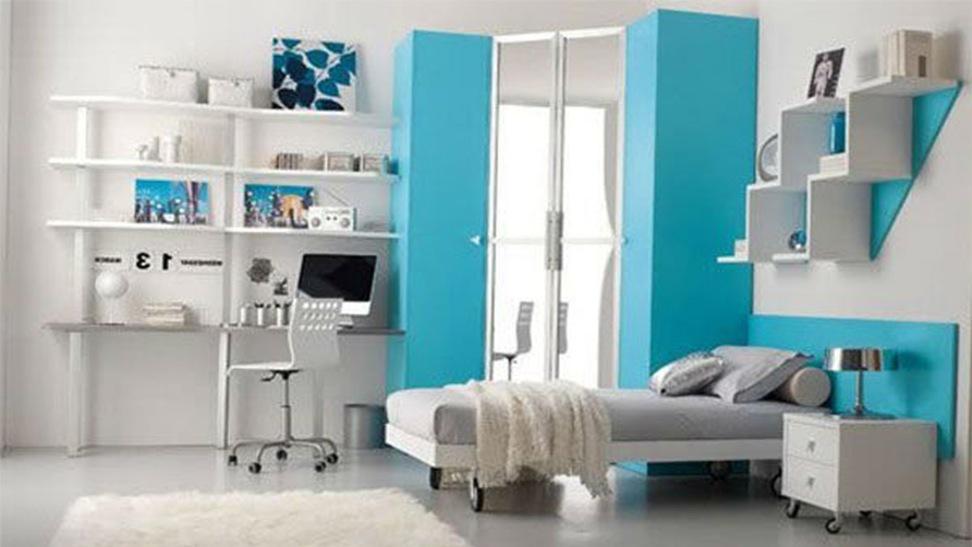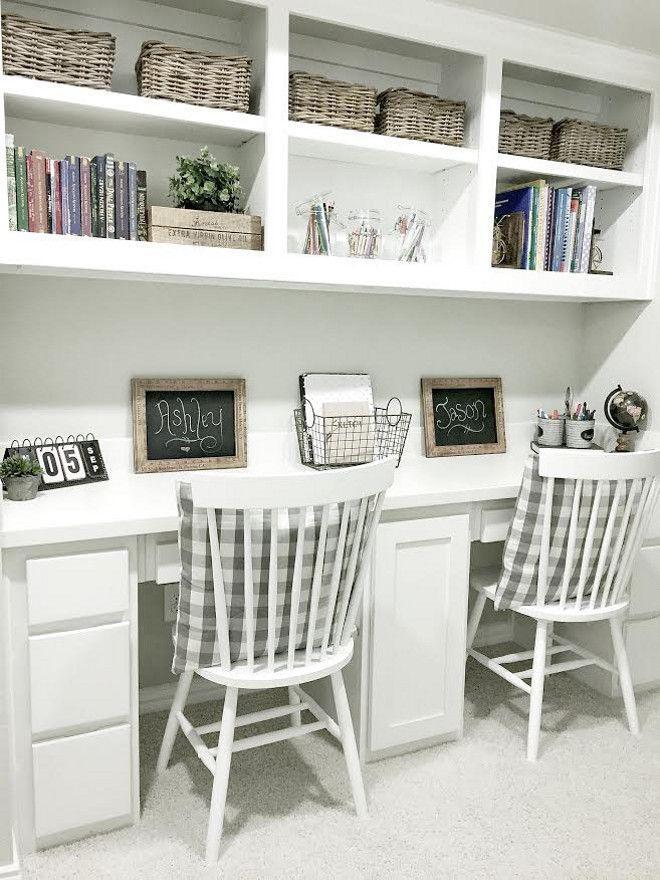The first image is the image on the left, the second image is the image on the right. For the images shown, is this caption "There is exactly one chair in the image on the left." true? Answer yes or no. Yes. 